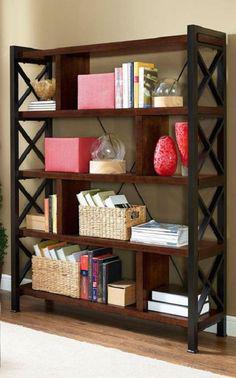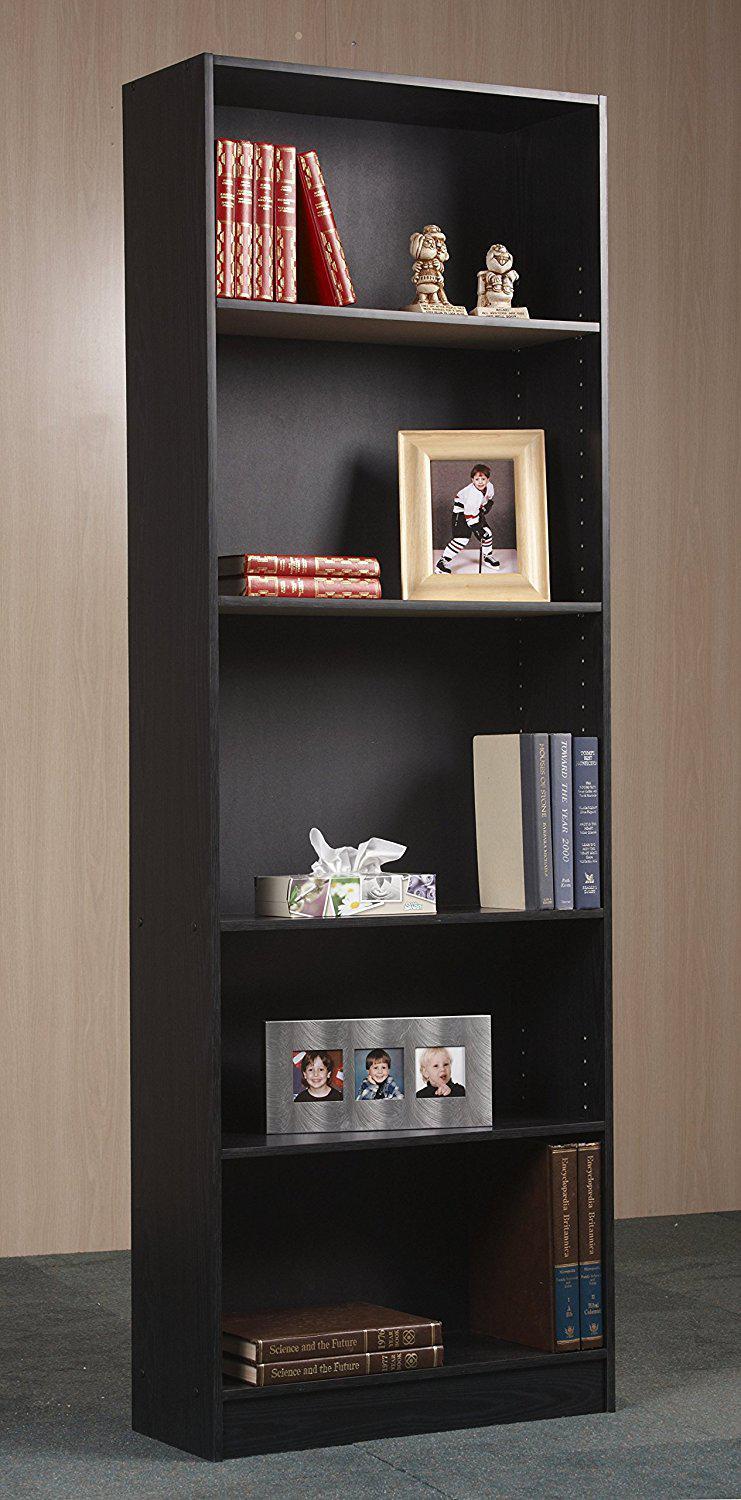The first image is the image on the left, the second image is the image on the right. For the images shown, is this caption "Two shelf units, one on short legs and one flush with the floor, are different widths and have a different number of shelves." true? Answer yes or no. Yes. The first image is the image on the left, the second image is the image on the right. Assess this claim about the two images: "One storage unit contains some blue bins with labels on the front, and the other holds several fiber-type baskets.". Correct or not? Answer yes or no. No. 